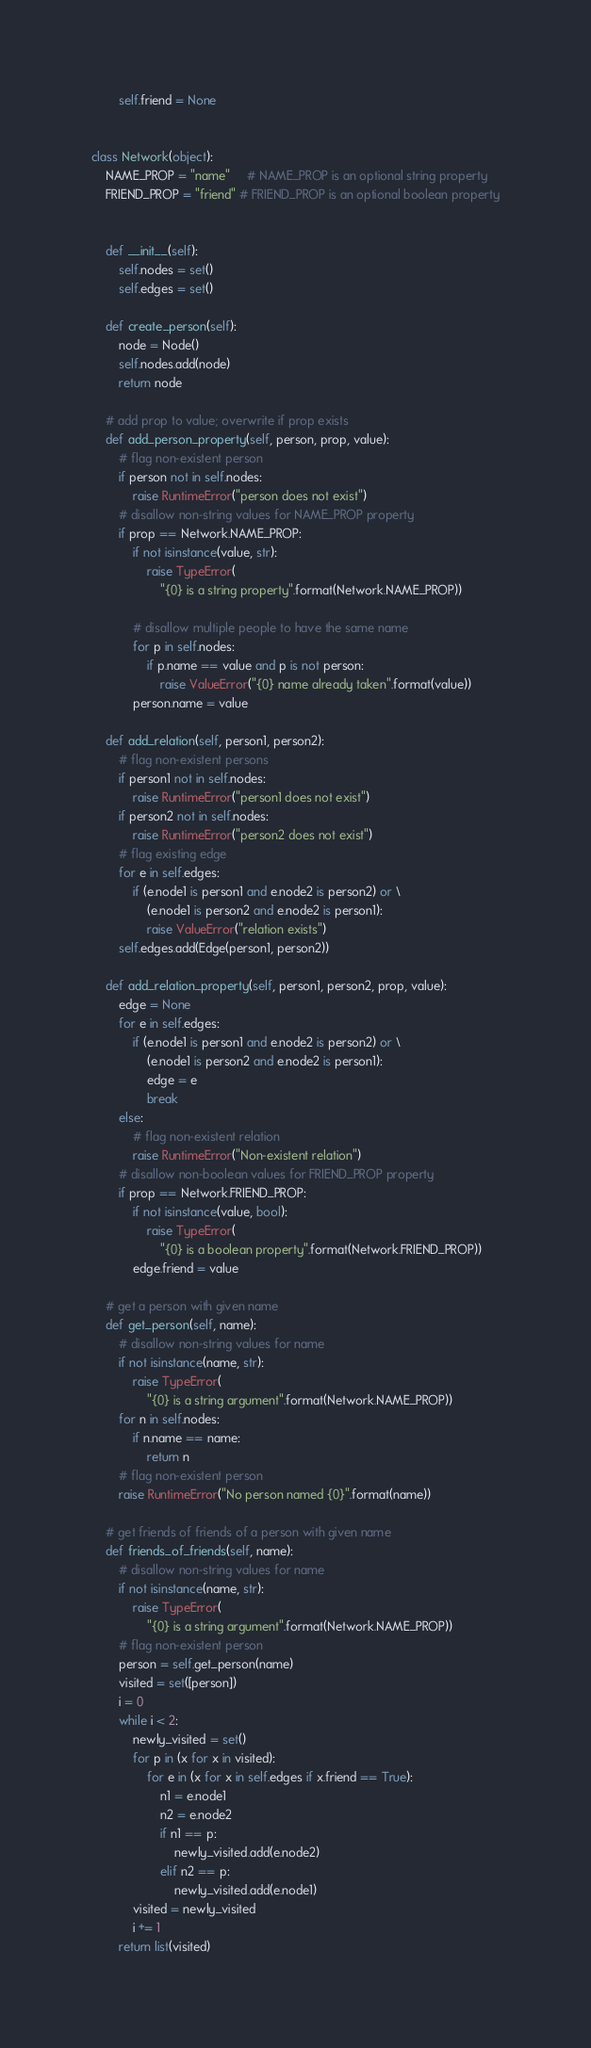Convert code to text. <code><loc_0><loc_0><loc_500><loc_500><_Python_>        self.friend = None


class Network(object):
    NAME_PROP = "name"     # NAME_PROP is an optional string property
    FRIEND_PROP = "friend" # FRIEND_PROP is an optional boolean property

    
    def __init__(self):
        self.nodes = set()
        self.edges = set()
        
    def create_person(self):
        node = Node()
        self.nodes.add(node)
        return node
    
    # add prop to value; overwrite if prop exists
    def add_person_property(self, person, prop, value):
        # flag non-existent person
        if person not in self.nodes:
            raise RuntimeError("person does not exist")
        # disallow non-string values for NAME_PROP property
        if prop == Network.NAME_PROP:
            if not isinstance(value, str):
                raise TypeError(
                    "{0} is a string property".format(Network.NAME_PROP))

            # disallow multiple people to have the same name
            for p in self.nodes:
                if p.name == value and p is not person:
                    raise ValueError("{0} name already taken".format(value))
            person.name = value
        
    def add_relation(self, person1, person2):
        # flag non-existent persons
        if person1 not in self.nodes:
            raise RuntimeError("person1 does not exist")
        if person2 not in self.nodes:
            raise RuntimeError("person2 does not exist")
        # flag existing edge
        for e in self.edges:
            if (e.node1 is person1 and e.node2 is person2) or \
                (e.node1 is person2 and e.node2 is person1):
                raise ValueError("relation exists")
        self.edges.add(Edge(person1, person2))

    def add_relation_property(self, person1, person2, prop, value):
        edge = None
        for e in self.edges:
            if (e.node1 is person1 and e.node2 is person2) or \
                (e.node1 is person2 and e.node2 is person1):
                edge = e
                break
        else:
            # flag non-existent relation
            raise RuntimeError("Non-existent relation")
        # disallow non-boolean values for FRIEND_PROP property
        if prop == Network.FRIEND_PROP:
            if not isinstance(value, bool):
                raise TypeError(
                    "{0} is a boolean property".format(Network.FRIEND_PROP))
            edge.friend = value

    # get a person with given name
    def get_person(self, name):
        # disallow non-string values for name
        if not isinstance(name, str):
            raise TypeError(
                "{0} is a string argument".format(Network.NAME_PROP))
        for n in self.nodes:
            if n.name == name:
                return n
        # flag non-existent person
        raise RuntimeError("No person named {0}".format(name))

    # get friends of friends of a person with given name
    def friends_of_friends(self, name):
        # disallow non-string values for name
        if not isinstance(name, str):
            raise TypeError(
                "{0} is a string argument".format(Network.NAME_PROP))
        # flag non-existent person
        person = self.get_person(name)
        visited = set([person])
        i = 0
        while i < 2:
            newly_visited = set()
            for p in (x for x in visited):
                for e in (x for x in self.edges if x.friend == True):
                    n1 = e.node1
                    n2 = e.node2
                    if n1 == p:
                        newly_visited.add(e.node2)
                    elif n2 == p:
                        newly_visited.add(e.node1)
            visited = newly_visited
            i += 1
        return list(visited)
</code> 